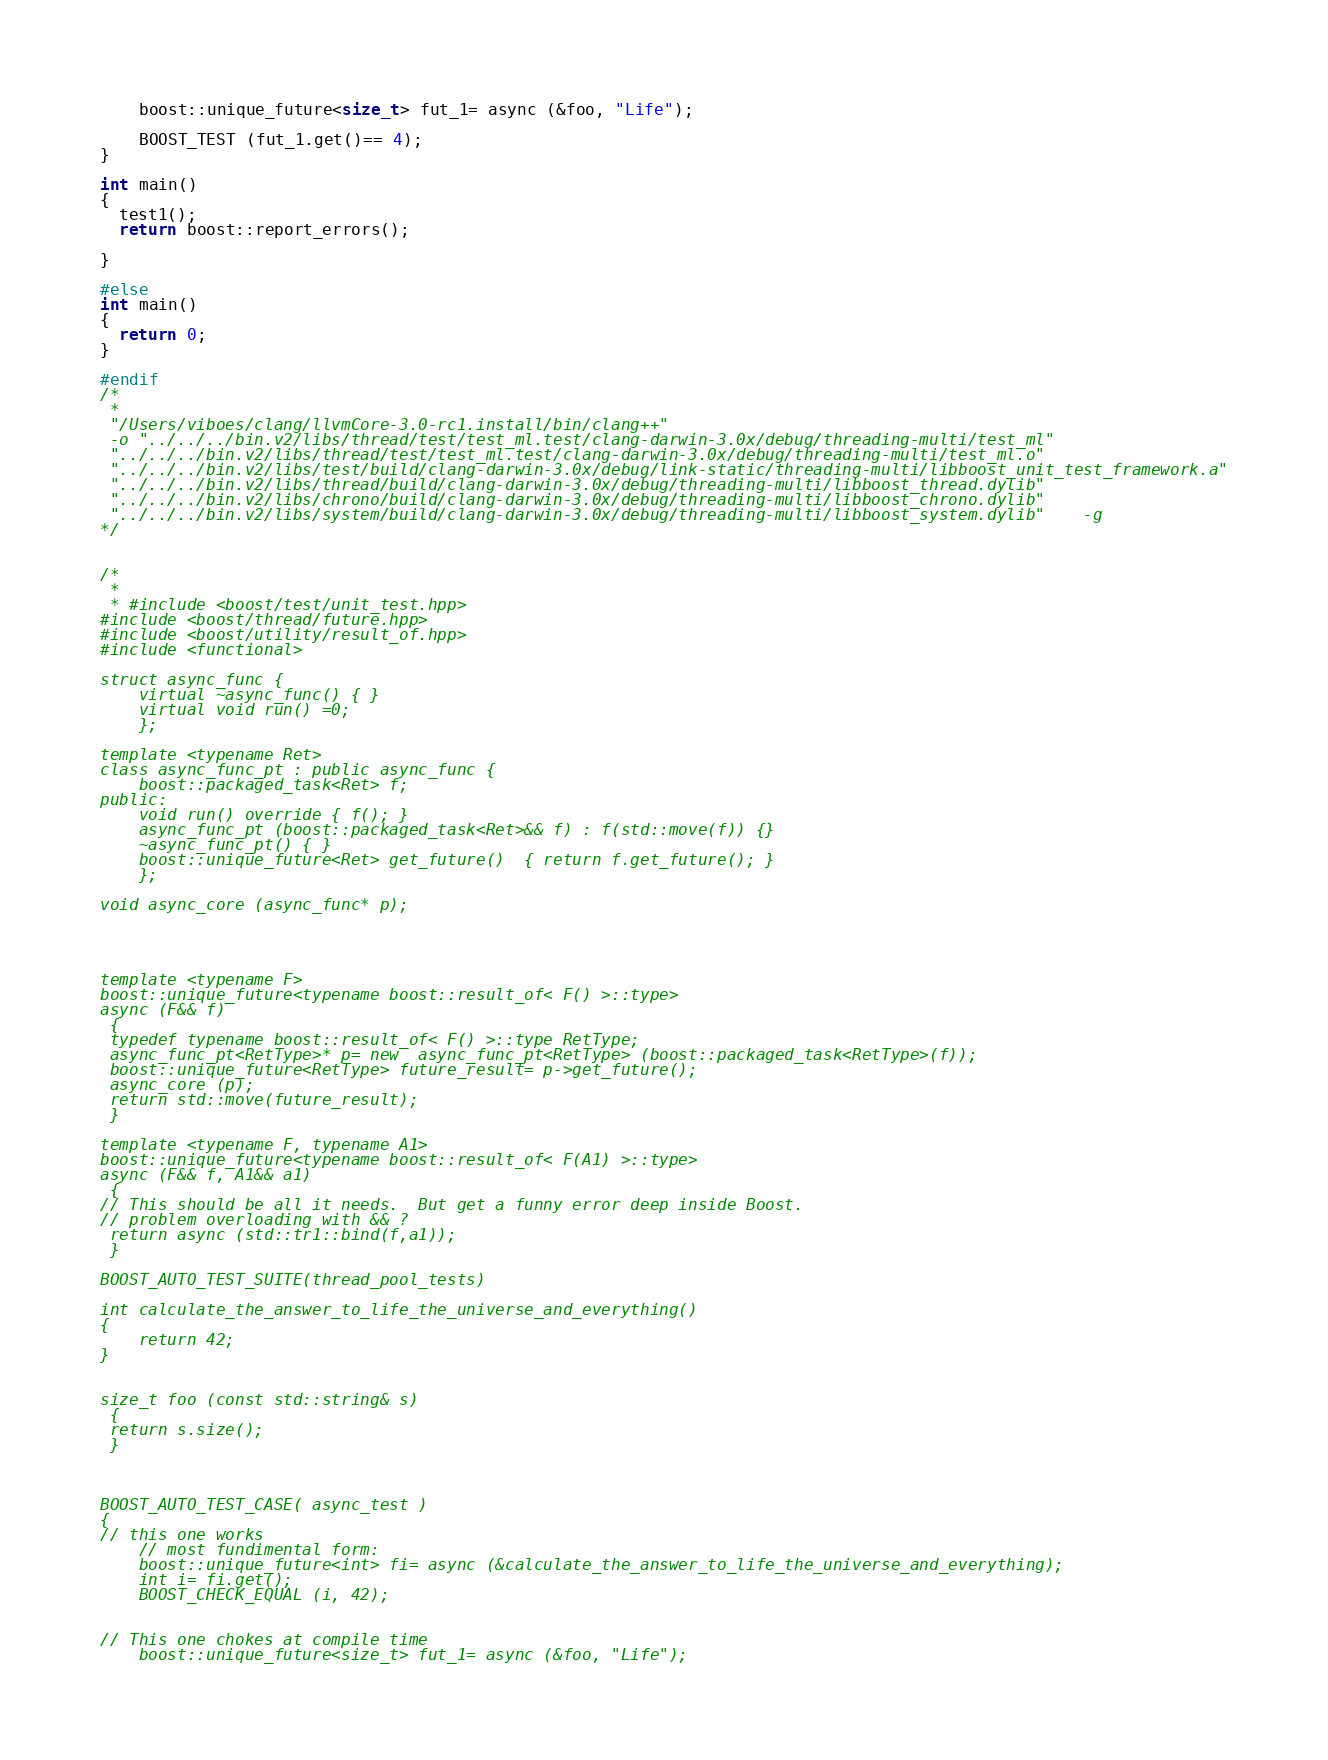Convert code to text. <code><loc_0><loc_0><loc_500><loc_500><_C++_>    boost::unique_future<size_t> fut_1= async (&foo, "Life");

    BOOST_TEST (fut_1.get()== 4);
}

int main()
{
  test1();
  return boost::report_errors();

}

#else
int main()
{
  return 0;
}

#endif
/*
 *
 "/Users/viboes/clang/llvmCore-3.0-rc1.install/bin/clang++"
 -o "../../../bin.v2/libs/thread/test/test_ml.test/clang-darwin-3.0x/debug/threading-multi/test_ml"
 "../../../bin.v2/libs/thread/test/test_ml.test/clang-darwin-3.0x/debug/threading-multi/test_ml.o"
 "../../../bin.v2/libs/test/build/clang-darwin-3.0x/debug/link-static/threading-multi/libboost_unit_test_framework.a"
 "../../../bin.v2/libs/thread/build/clang-darwin-3.0x/debug/threading-multi/libboost_thread.dylib"
 "../../../bin.v2/libs/chrono/build/clang-darwin-3.0x/debug/threading-multi/libboost_chrono.dylib"
 "../../../bin.v2/libs/system/build/clang-darwin-3.0x/debug/threading-multi/libboost_system.dylib"    -g
*/


/*
 *
 * #include <boost/test/unit_test.hpp>
#include <boost/thread/future.hpp>
#include <boost/utility/result_of.hpp>
#include <functional>

struct async_func {
    virtual ~async_func() { }
    virtual void run() =0;
    };

template <typename Ret>
class async_func_pt : public async_func {
    boost::packaged_task<Ret> f;
public:
    void run() override { f(); }
    async_func_pt (boost::packaged_task<Ret>&& f) : f(std::move(f)) {}
    ~async_func_pt() { }
    boost::unique_future<Ret> get_future()  { return f.get_future(); }
    };

void async_core (async_func* p);




template <typename F>
boost::unique_future<typename boost::result_of< F() >::type>
async (F&& f)
 {
 typedef typename boost::result_of< F() >::type RetType;
 async_func_pt<RetType>* p= new  async_func_pt<RetType> (boost::packaged_task<RetType>(f));
 boost::unique_future<RetType> future_result= p->get_future();
 async_core (p);
 return std::move(future_result);
 }

template <typename F, typename A1>
boost::unique_future<typename boost::result_of< F(A1) >::type>
async (F&& f, A1&& a1)
 {
// This should be all it needs.  But get a funny error deep inside Boost.
// problem overloading with && ?
 return async (std::tr1::bind(f,a1));
 }

BOOST_AUTO_TEST_SUITE(thread_pool_tests)

int calculate_the_answer_to_life_the_universe_and_everything()
{
    return 42;
}


size_t foo (const std::string& s)
 {
 return s.size();
 }



BOOST_AUTO_TEST_CASE( async_test )
{
// this one works
    // most fundimental form:
    boost::unique_future<int> fi= async (&calculate_the_answer_to_life_the_universe_and_everything);
    int i= fi.get();
    BOOST_CHECK_EQUAL (i, 42);


// This one chokes at compile time
    boost::unique_future<size_t> fut_1= async (&foo, "Life");
</code> 